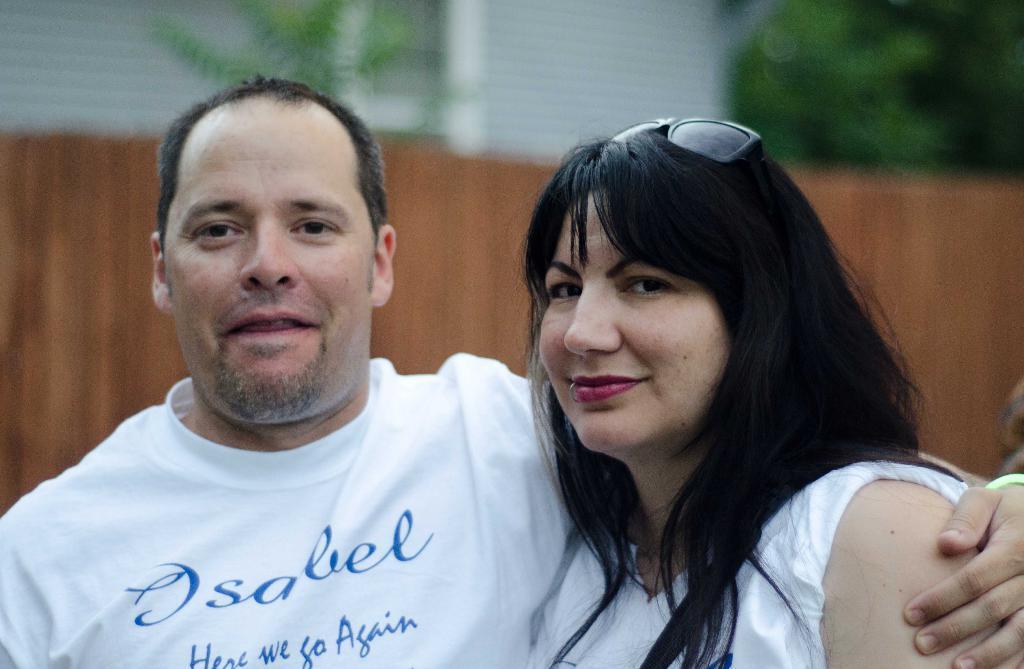Can you describe this image briefly? In this picture there is a man who is wearing t-shirt, beside him we can see a woman who is wearing goggles and white t-shirt. In the background we can see the building and wooden partition. In the top right corner we can see the trees. 